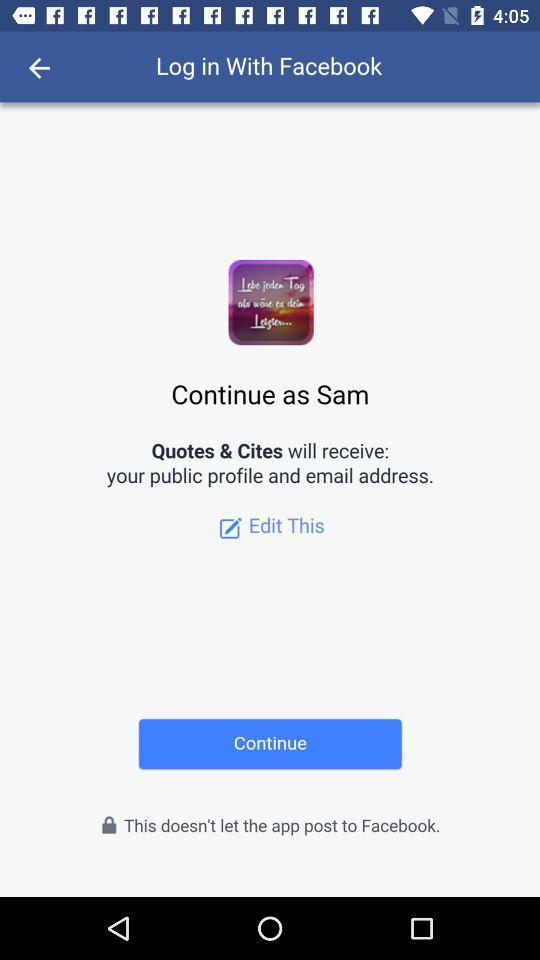What is the login name? The login name is Sam. 